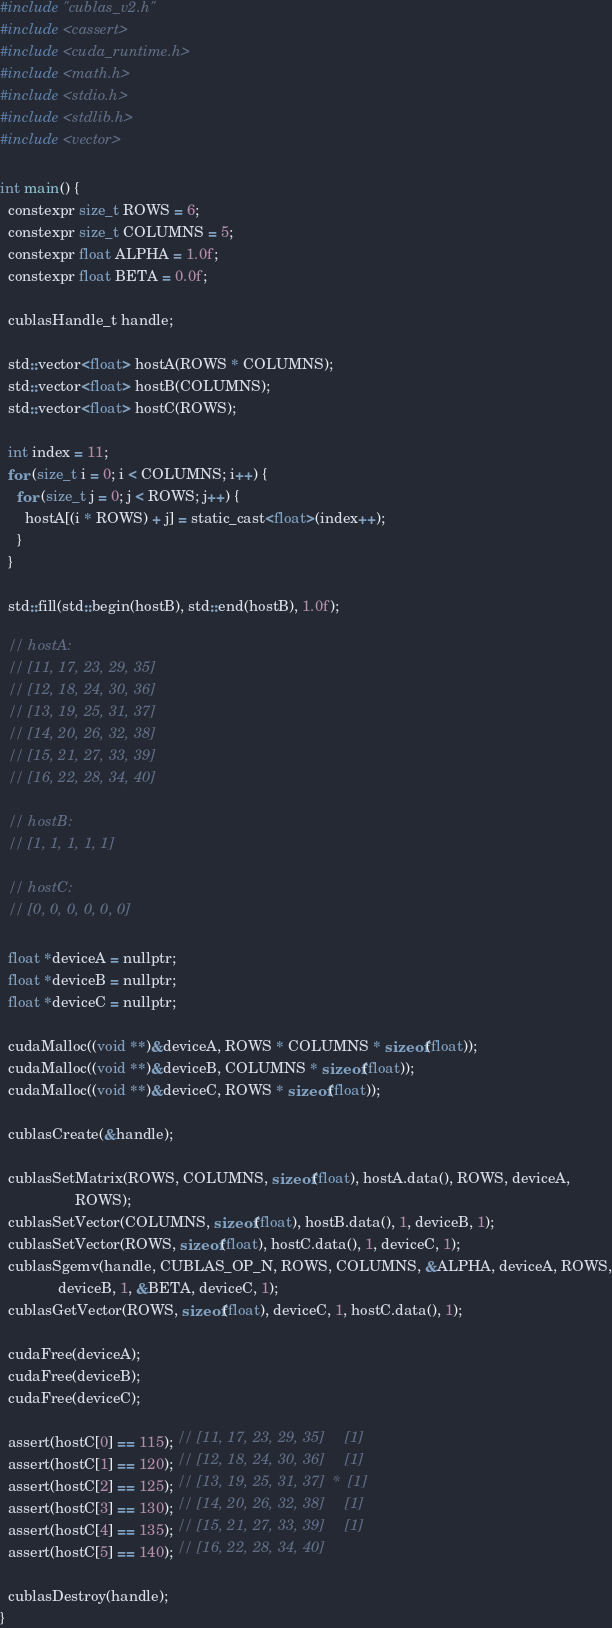<code> <loc_0><loc_0><loc_500><loc_500><_Cuda_>#include "cublas_v2.h"
#include <cassert>
#include <cuda_runtime.h>
#include <math.h>
#include <stdio.h>
#include <stdlib.h>
#include <vector>

int main() {
  constexpr size_t ROWS = 6;
  constexpr size_t COLUMNS = 5;
  constexpr float ALPHA = 1.0f;
  constexpr float BETA = 0.0f;

  cublasHandle_t handle;

  std::vector<float> hostA(ROWS * COLUMNS);
  std::vector<float> hostB(COLUMNS);
  std::vector<float> hostC(ROWS);

  int index = 11;
  for (size_t i = 0; i < COLUMNS; i++) {
    for (size_t j = 0; j < ROWS; j++) {
      hostA[(i * ROWS) + j] = static_cast<float>(index++);
    }
  }

  std::fill(std::begin(hostB), std::end(hostB), 1.0f);

  // hostA:
  // [11, 17, 23, 29, 35]
  // [12, 18, 24, 30, 36]
  // [13, 19, 25, 31, 37]
  // [14, 20, 26, 32, 38]
  // [15, 21, 27, 33, 39]
  // [16, 22, 28, 34, 40]

  // hostB:
  // [1, 1, 1, 1, 1]

  // hostC:
  // [0, 0, 0, 0, 0, 0]

  float *deviceA = nullptr;
  float *deviceB = nullptr;
  float *deviceC = nullptr;

  cudaMalloc((void **)&deviceA, ROWS * COLUMNS * sizeof(float));
  cudaMalloc((void **)&deviceB, COLUMNS * sizeof(float));
  cudaMalloc((void **)&deviceC, ROWS * sizeof(float));

  cublasCreate(&handle);

  cublasSetMatrix(ROWS, COLUMNS, sizeof(float), hostA.data(), ROWS, deviceA,
                  ROWS);
  cublasSetVector(COLUMNS, sizeof(float), hostB.data(), 1, deviceB, 1);
  cublasSetVector(ROWS, sizeof(float), hostC.data(), 1, deviceC, 1);
  cublasSgemv(handle, CUBLAS_OP_N, ROWS, COLUMNS, &ALPHA, deviceA, ROWS,
              deviceB, 1, &BETA, deviceC, 1);
  cublasGetVector(ROWS, sizeof(float), deviceC, 1, hostC.data(), 1);

  cudaFree(deviceA);
  cudaFree(deviceB);
  cudaFree(deviceC);

  assert(hostC[0] == 115); // [11, 17, 23, 29, 35]     [1]
  assert(hostC[1] == 120); // [12, 18, 24, 30, 36]     [1]
  assert(hostC[2] == 125); // [13, 19, 25, 31, 37]  *  [1]
  assert(hostC[3] == 130); // [14, 20, 26, 32, 38]     [1]
  assert(hostC[4] == 135); // [15, 21, 27, 33, 39]     [1]
  assert(hostC[5] == 140); // [16, 22, 28, 34, 40]

  cublasDestroy(handle);
}</code> 